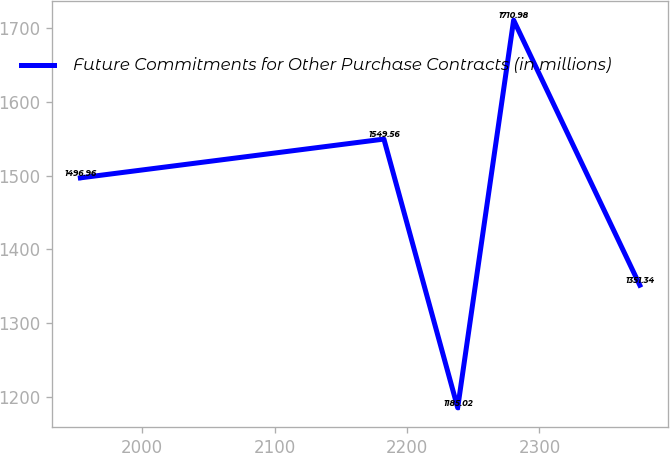Convert chart. <chart><loc_0><loc_0><loc_500><loc_500><line_chart><ecel><fcel>Future Commitments for Other Purchase Contracts (in millions)<nl><fcel>1953.27<fcel>1496.96<nl><fcel>2182.52<fcel>1549.56<nl><fcel>2238.25<fcel>1185.02<nl><fcel>2280.5<fcel>1710.98<nl><fcel>2375.79<fcel>1351.34<nl></chart> 